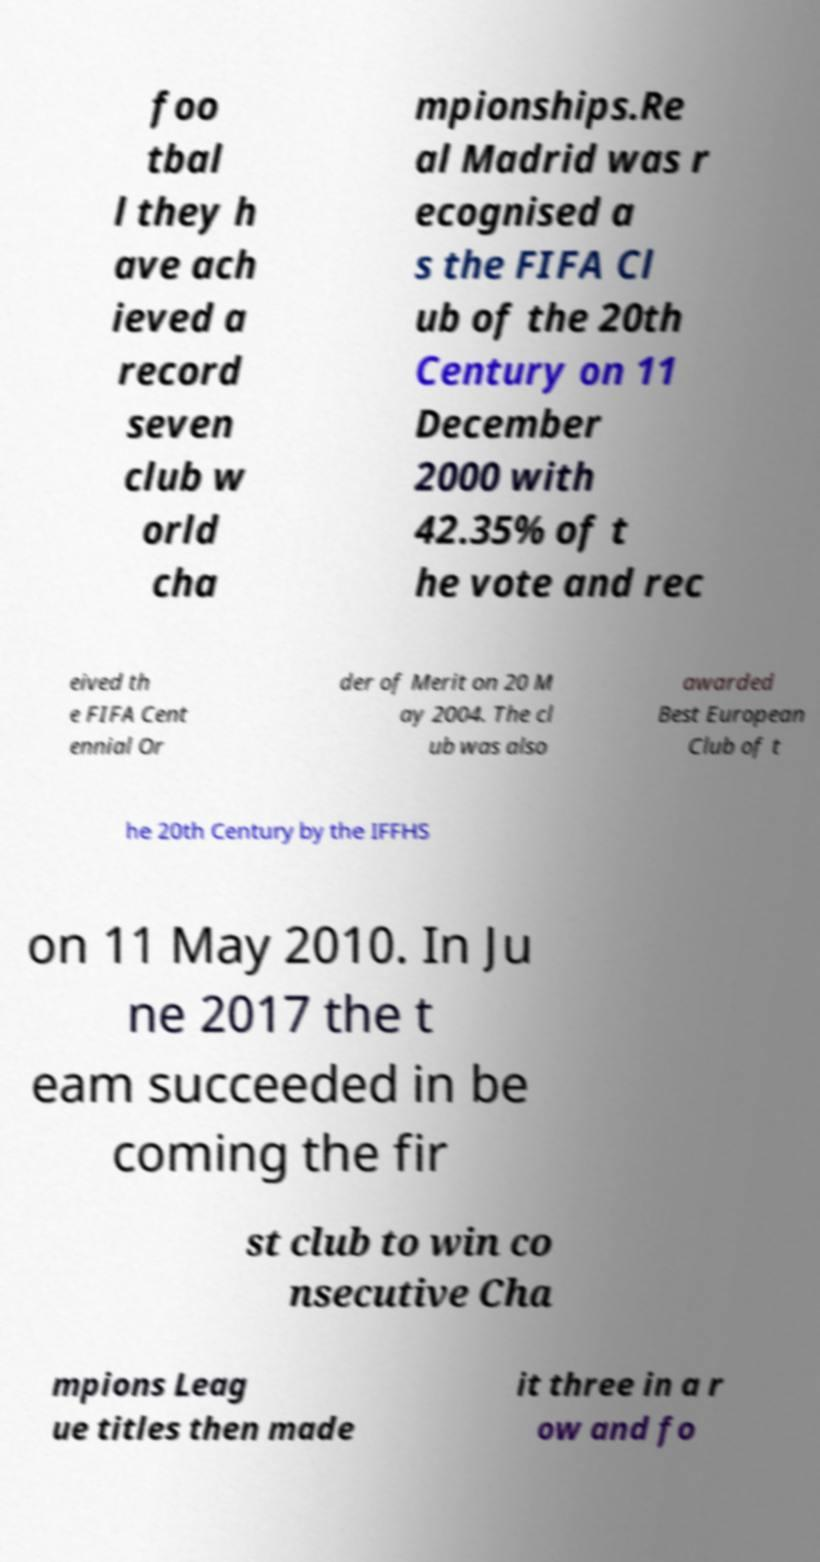For documentation purposes, I need the text within this image transcribed. Could you provide that? foo tbal l they h ave ach ieved a record seven club w orld cha mpionships.Re al Madrid was r ecognised a s the FIFA Cl ub of the 20th Century on 11 December 2000 with 42.35% of t he vote and rec eived th e FIFA Cent ennial Or der of Merit on 20 M ay 2004. The cl ub was also awarded Best European Club of t he 20th Century by the IFFHS on 11 May 2010. In Ju ne 2017 the t eam succeeded in be coming the fir st club to win co nsecutive Cha mpions Leag ue titles then made it three in a r ow and fo 